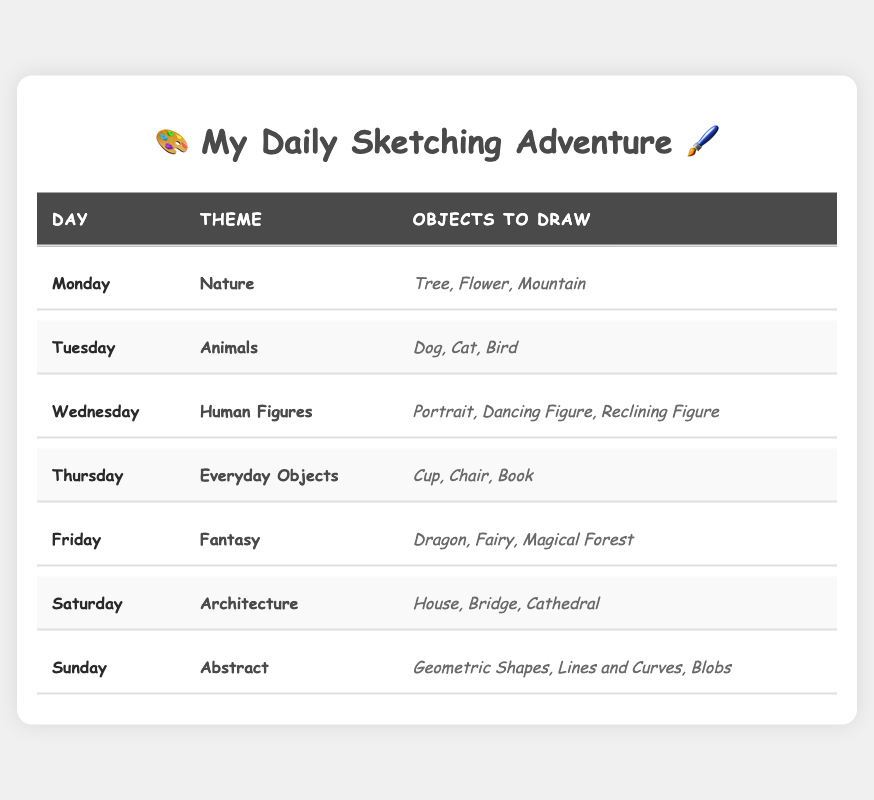What is the theme for Friday? According to the table, the theme listed for Friday is "Fantasy".
Answer: Fantasy How many objects are there to draw on Tuesday? On Tuesday, the objects listed to draw are "Dog", "Cat", and "Bird", which makes a total of 3 objects.
Answer: 3 Which day focuses on human figures? The data shows that Wednesday is the day dedicated to human figures.
Answer: Wednesday On which day do you sketch architectural themes? The table indicates that Saturday is the day for sketching architecture themes.
Answer: Saturday List the objects to draw on Sunday. The objects scheduled for Sunday are "Geometric Shapes", "Lines and Curves", and "Blobs".
Answer: Geometric Shapes, Lines and Curves, Blobs Is "Bridge" one of the objects for Thursday? Based on the table, "Bridge" is not listed as an object to draw on Thursday; instead, the objects are "Cup", "Chair", and "Book".
Answer: No Which theme has the most objects listed? By examining the table, each day's theme is associated with 3 objects, so no theme has more than others.
Answer: None What is the theme for the day after Monday? The day after Monday is Tuesday, and the theme for Tuesday is "Animals".
Answer: Animals On which day do you sketch everyday objects? The data specifies that Thursday is the day meant for sketching everyday objects.
Answer: Thursday For which day is "Magical Forest" listed as an object? According to the table, "Magical Forest" is an object listed for Friday under the theme of "Fantasy".
Answer: Friday If you combined the objects from Monday and Tuesday, how many objects would you have? Monday has 3 objects ("Tree", "Flower", "Mountain") and Tuesday also has 3 objects ("Dog", "Cat", "Bird"). Summing these gives 3 + 3 = 6 objects in total.
Answer: 6 What would be the theme for the sketching practice if the week started over? If the week started over, the theme for Monday would again be "Nature".
Answer: Nature Which day's theme is related to animals? The table shows that Tuesday's theme is related to animals.
Answer: Tuesday Are there any themes that include shapes? Yes, the theme for Sunday involves shapes, specifically "Geometric Shapes".
Answer: Yes Which theme has a mythical creature listed? The theme for Friday includes the mythical creature "Dragon".
Answer: Fantasy Count the total number of different themes in the schedule. There are 7 distinct themes listed from Monday to Sunday: Nature, Animals, Human Figures, Everyday Objects, Fantasy, Architecture, and Abstract. So the total is 7.
Answer: 7 